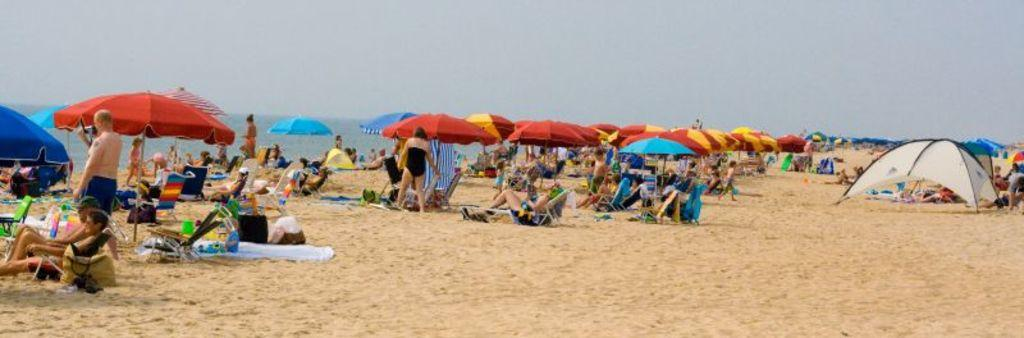What type of location is depicted in the image? There is a beach in the image. What are the people on the beach doing? Some people are standing, while others are lying on chairs on the beach. What objects provide shade on the beach? There are umbrellas on the beach. Is there any shelter or structure on the beach? Yes, there is a tent on the beach. What can be seen beyond the beach in the image? The sea is visible in the image. What type of order is being taken by the people on the beach? There is no indication in the image that people are taking any orders, as they are simply enjoying the beach. 